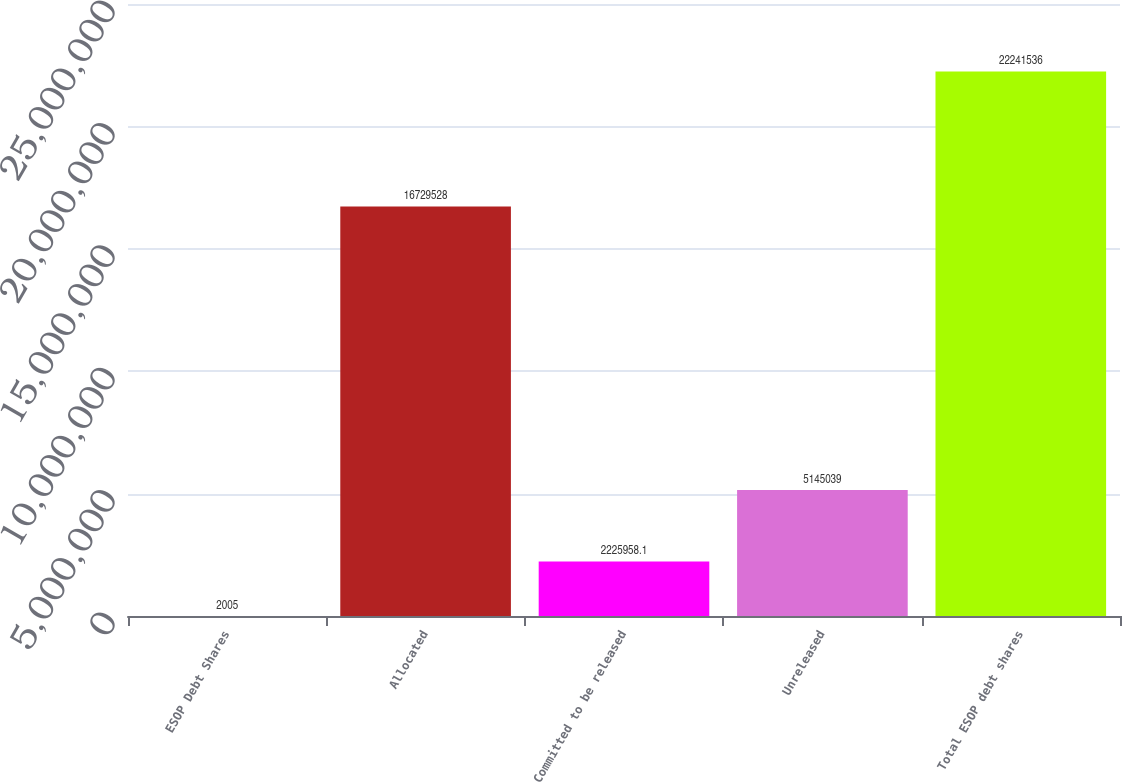<chart> <loc_0><loc_0><loc_500><loc_500><bar_chart><fcel>ESOP Debt Shares<fcel>Allocated<fcel>Committed to be released<fcel>Unreleased<fcel>Total ESOP debt shares<nl><fcel>2005<fcel>1.67295e+07<fcel>2.22596e+06<fcel>5.14504e+06<fcel>2.22415e+07<nl></chart> 